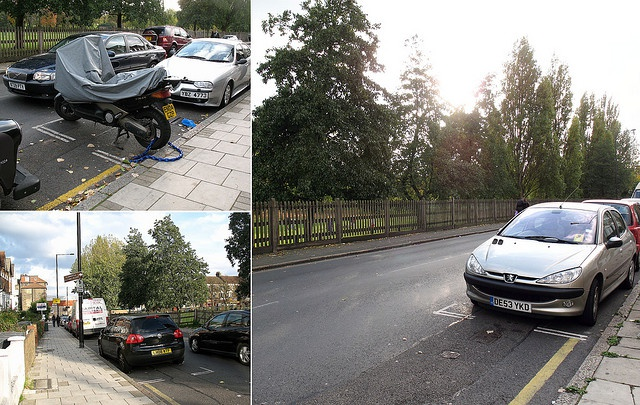Describe the objects in this image and their specific colors. I can see car in black, white, gray, and darkgray tones, motorcycle in black, gray, and darkgray tones, car in black, white, gray, and darkgray tones, car in black, gray, darkgray, and darkgreen tones, and car in black, gray, and blue tones in this image. 